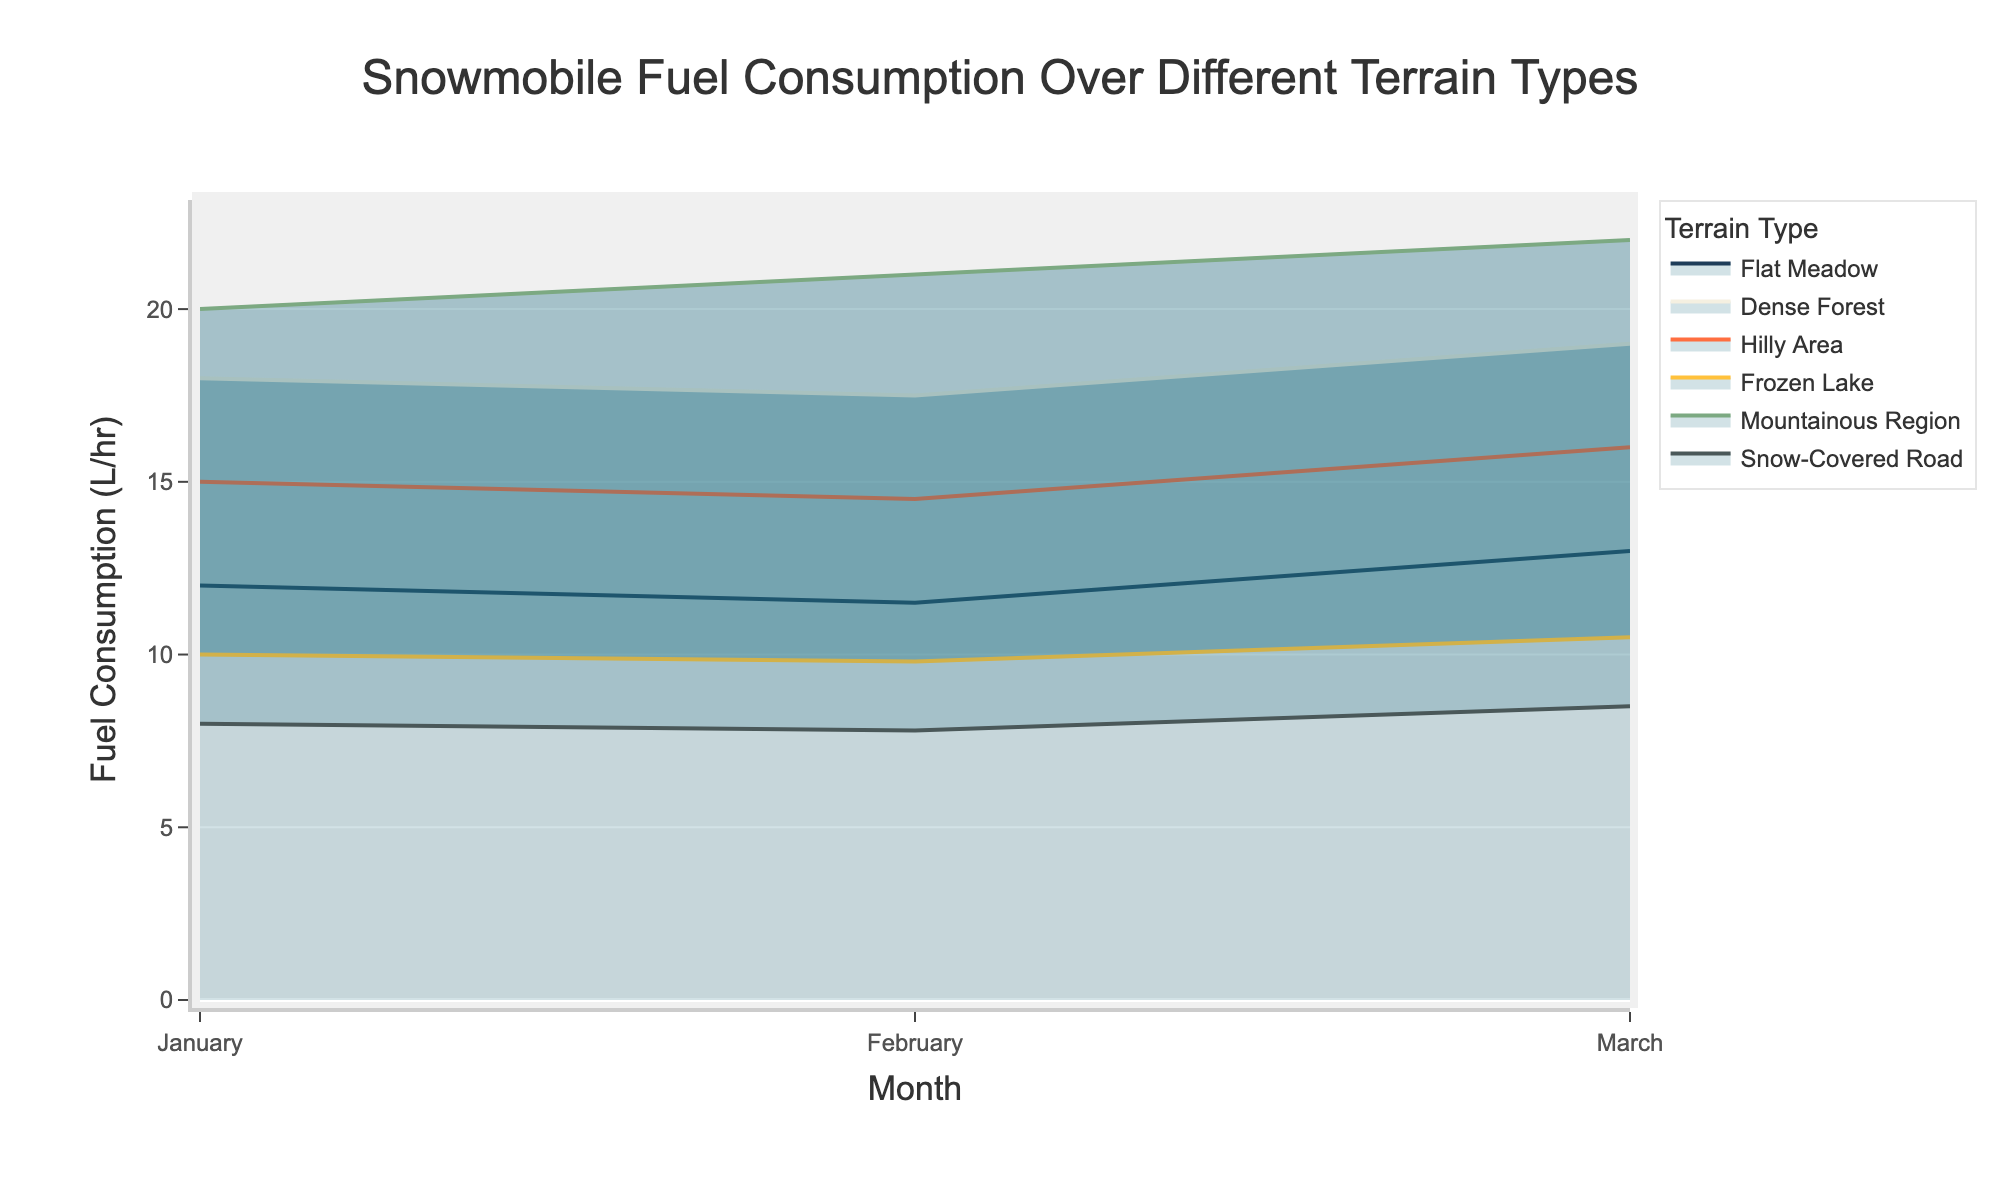What is the title of the figure? Look at the text located at the top of the figure, which typically states the subject of the chart.
Answer: Snowmobile Fuel Consumption Over Different Terrain Types What are the units on the y-axis? Observe the y-axis title to identify the measurement units used for the vertical axis.
Answer: Liters per hour (L/hr) Which terrain type has the highest fuel consumption in March? Examine the area chart for the highest point among different terrains for the month of March.
Answer: Mountainous Region How does the fuel consumption for the Dense Forest terrain change from January to March? Compare the fuel consumption values for Dense Forest terrain in January, February, and March.
Answer: It increases from 18 L/hr in January to 19 L/hr in March Which terrain type has the lowest fuel consumption in February? Identify the lowest point on the area chart for the month of February.
Answer: Snow-Covered Road What is the difference in fuel consumption between Flat Meadow and Frozen Lake in January? Subtract the fuel consumption value for Frozen Lake from that of Flat Meadow in January.
Answer: 2 liters per hour What is the average fuel consumption for Hilly Area across the three months? Sum the fuel consumption values for Hilly Area in January, February, and March, then divide by three for the average.
Answer: (15 + 14.5 + 16) / 3 = 15.167 Which terrain type shows a steady increase in fuel consumption from January to March? Look for a consistent upward trend in the area chart from January to March.
Answer: Mountainous Region Compare the fuel consumption of Flat Meadow and Dense Forest in February. Which one is higher and by how much? Examine the values for both terrains in February and subtract Flat Meadow's value from Dense Forest's value to determine the difference.
Answer: Dense Forest is higher by 6 liters per hour What is the combined fuel consumption for Frozen Lake and Snow-Covered Road in March? Add the fuel consumption values for Frozen Lake and Snow-Covered Road in March.
Answer: 10.5 + 8.5 = 19 liters per hour 